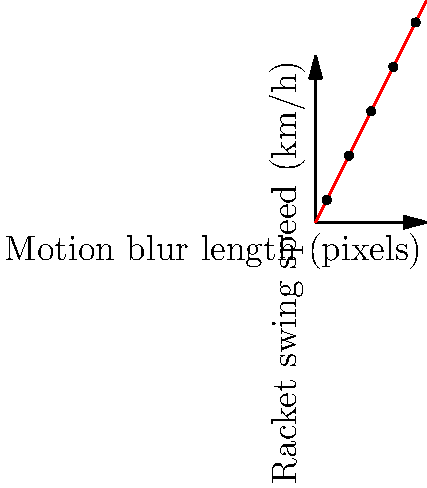As an amateur tennis player, you're analyzing action shots to estimate racket swing speeds. The graph shows the relationship between motion blur length in pixels and racket swing speed in km/h. If a new action shot has a motion blur of 40 pixels, what is the estimated racket swing speed? To estimate the racket swing speed from the motion blur length, we need to follow these steps:

1. Observe the graph: It shows a linear relationship between motion blur length (x-axis) and racket swing speed (y-axis).

2. Identify the pattern: The red line represents the best-fit line for the data points, which can be described by the equation $y = 2x$, where:
   - $y$ is the racket swing speed in km/h
   - $x$ is the motion blur length in pixels

3. Use the given information: The new action shot has a motion blur of 40 pixels, so $x = 40$.

4. Apply the equation: $y = 2x$
   Substitute $x = 40$:
   $y = 2 * 40 = 80$

5. Interpret the result: The estimated racket swing speed is 80 km/h.

This linear relationship allows us to quickly estimate swing speeds from motion blur in action shots, which can be useful for analyzing and improving our tennis technique.
Answer: 80 km/h 